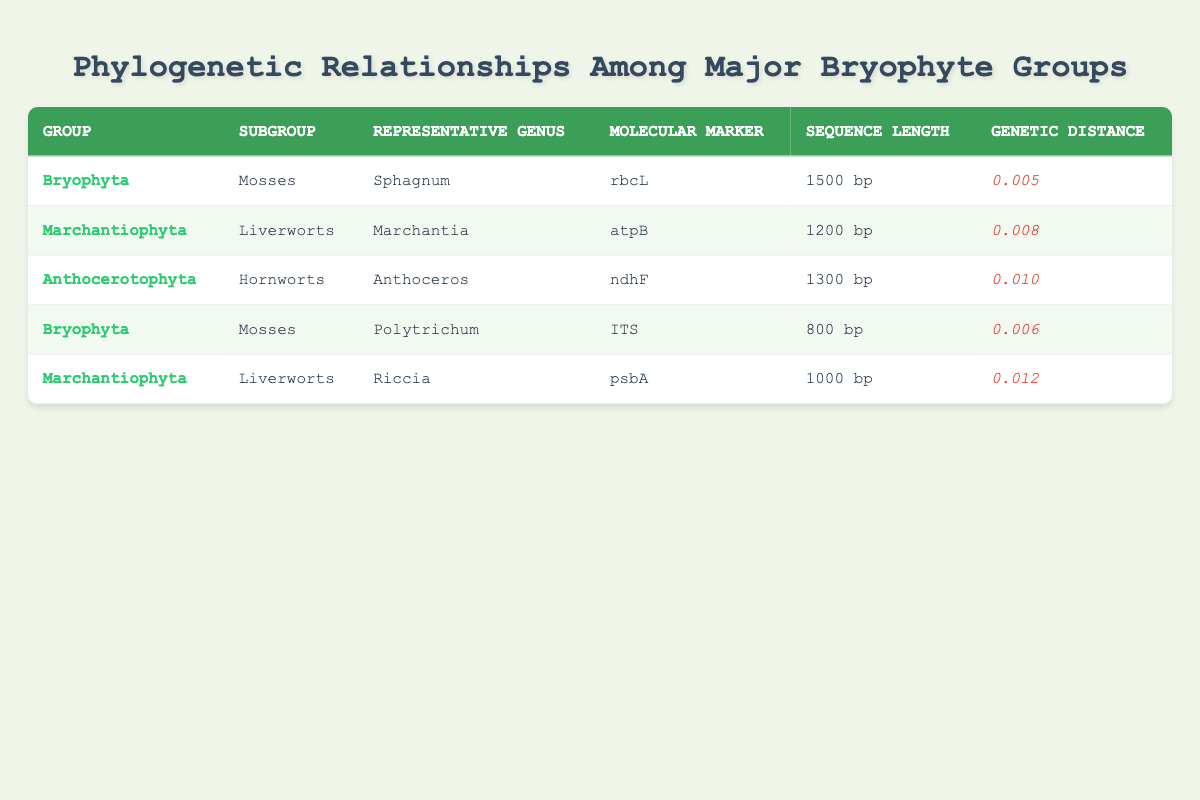What is the representative genus for the group Bryophyta? The group Bryophyta has two entries in the table, with representative genera listed as Sphagnum and Polytrichum. Either could be a correct answer, so the simplest approach is to pick the first one, Sphagnum.
Answer: Sphagnum Which molecular marker is used for the representative genus Marchantia? According to the table, the molecular marker used for the representative genus Marchantia (which belongs to the group Marchantiophyta) is atpB.
Answer: atpB What is the genetic distance for the Liverworts subgroup? There are two rows for the Liverworts subgroup under the Marchantiophyta group. The genetic distances are 0.008 for Marchantia and 0.012 for Riccia. The maximum genetic distance for this subgroup is 0.012.
Answer: 0.012 Is the sequence length for Hornworts greater than that of Mosses? The sequence length for the Hornwort representative genus Anthoceros is 1300 bp, while the sequence lengths for the Mosses (Sphagnum and Polytrichum) are 1500 bp and 800 bp, respectively. Since 1300 bp is less than the maximum of 1500 bp, the answer is false.
Answer: No What is the average genetic distance of the groups represented in the table? The genetic distances listed are 0.005 (for Sphagnum), 0.008 (for Marchantia), 0.010 (for Anthoceros), 0.006 (for Polytrichum), and 0.012 (for Riccia). Sum these distances to get 0.005 + 0.008 + 0.010 + 0.006 + 0.012 = 0.041. There are 5 data points, so the average is 0.041/5 = 0.0082.
Answer: 0.0082 